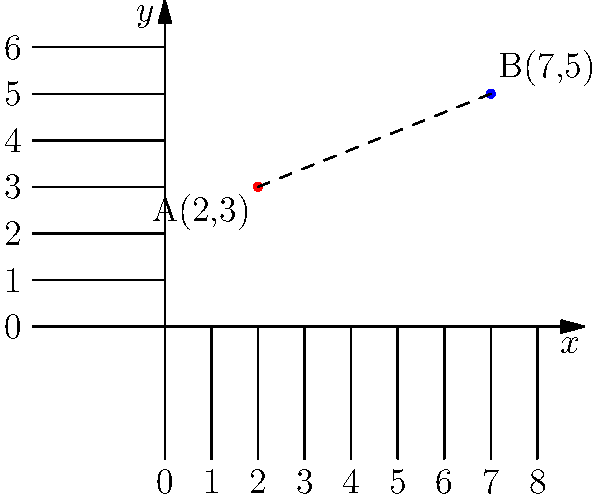As a journalist reporting on a developing story, you need to quickly calculate the distance between two key locations on a map. The coordinates of these locations are represented as points A(2,3) and B(7,5) on a coordinate plane. What is the distance between these two points? Round your answer to two decimal places. To find the distance between two points on a coordinate plane, we can use the distance formula, which is derived from the Pythagorean theorem:

$$d = \sqrt{(x_2-x_1)^2 + (y_2-y_1)^2}$$

Where $(x_1,y_1)$ are the coordinates of the first point and $(x_2,y_2)$ are the coordinates of the second point.

Let's plug in our values:
- Point A: $(x_1,y_1) = (2,3)$
- Point B: $(x_2,y_2) = (7,5)$

Now, let's calculate:

1) $d = \sqrt{(7-2)^2 + (5-3)^2}$

2) $d = \sqrt{5^2 + 2^2}$

3) $d = \sqrt{25 + 4}$

4) $d = \sqrt{29}$

5) $d \approx 5.3852$

Rounding to two decimal places:

$d \approx 5.39$

Therefore, the distance between points A and B is approximately 5.39 units.
Answer: 5.39 units 